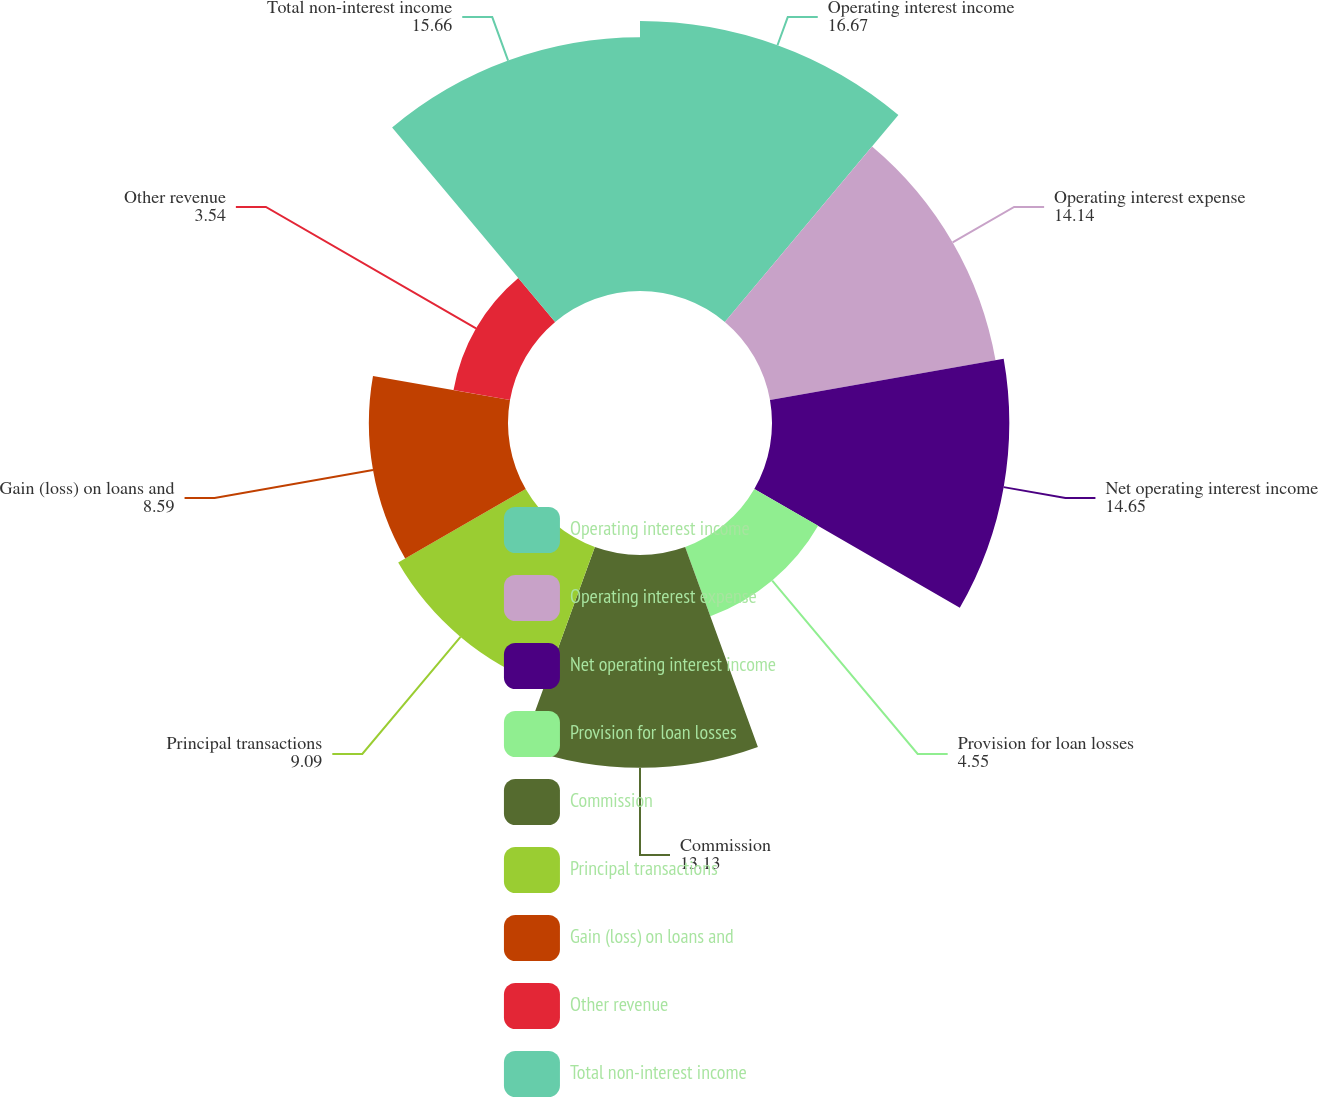Convert chart to OTSL. <chart><loc_0><loc_0><loc_500><loc_500><pie_chart><fcel>Operating interest income<fcel>Operating interest expense<fcel>Net operating interest income<fcel>Provision for loan losses<fcel>Commission<fcel>Principal transactions<fcel>Gain (loss) on loans and<fcel>Other revenue<fcel>Total non-interest income<nl><fcel>16.67%<fcel>14.14%<fcel>14.65%<fcel>4.55%<fcel>13.13%<fcel>9.09%<fcel>8.59%<fcel>3.54%<fcel>15.66%<nl></chart> 